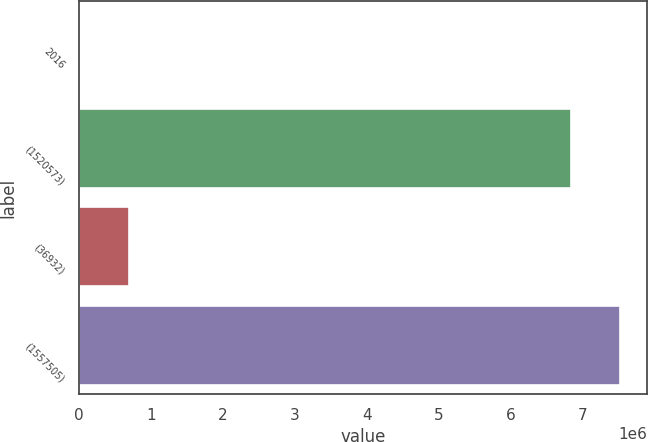Convert chart to OTSL. <chart><loc_0><loc_0><loc_500><loc_500><bar_chart><fcel>2016<fcel>(1520573)<fcel>(36932)<fcel>(1557505)<nl><fcel>2015<fcel>6.84012e+06<fcel>693969<fcel>7.53207e+06<nl></chart> 